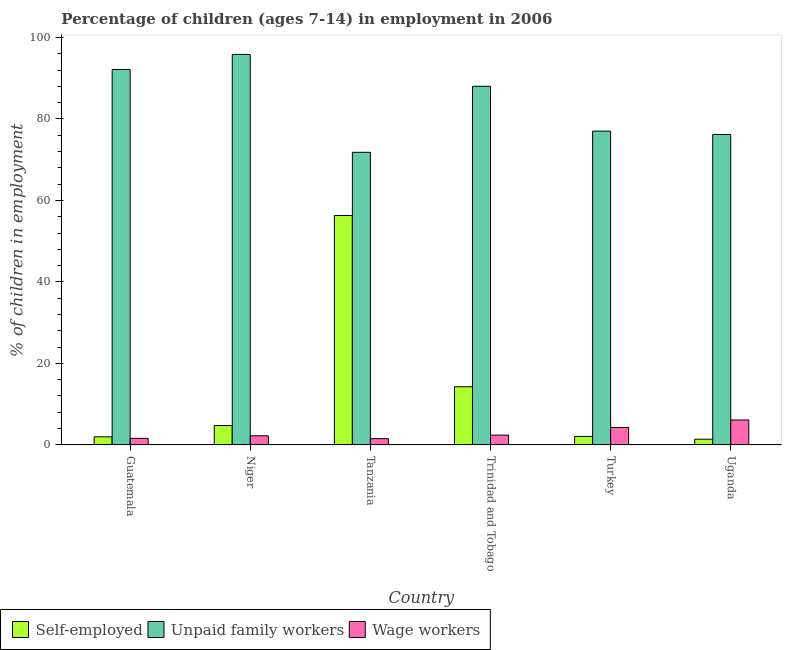How many different coloured bars are there?
Your response must be concise. 3. How many groups of bars are there?
Your response must be concise. 6. Are the number of bars per tick equal to the number of legend labels?
Your answer should be very brief. Yes. Are the number of bars on each tick of the X-axis equal?
Ensure brevity in your answer.  Yes. How many bars are there on the 6th tick from the left?
Offer a very short reply. 3. How many bars are there on the 3rd tick from the right?
Offer a very short reply. 3. What is the label of the 2nd group of bars from the left?
Offer a very short reply. Niger. What is the percentage of self employed children in Niger?
Your answer should be very brief. 4.75. Across all countries, what is the maximum percentage of children employed as unpaid family workers?
Keep it short and to the point. 95.83. Across all countries, what is the minimum percentage of children employed as unpaid family workers?
Offer a terse response. 71.8. In which country was the percentage of self employed children maximum?
Provide a short and direct response. Tanzania. In which country was the percentage of children employed as unpaid family workers minimum?
Give a very brief answer. Tanzania. What is the total percentage of self employed children in the graph?
Give a very brief answer. 80.78. What is the difference between the percentage of children employed as wage workers in Niger and that in Turkey?
Your answer should be very brief. -2.05. What is the difference between the percentage of self employed children in Niger and the percentage of children employed as wage workers in Guatemala?
Your response must be concise. 3.15. What is the average percentage of self employed children per country?
Ensure brevity in your answer.  13.46. What is the difference between the percentage of children employed as wage workers and percentage of self employed children in Uganda?
Keep it short and to the point. 4.71. What is the ratio of the percentage of self employed children in Niger to that in Turkey?
Keep it short and to the point. 2.28. Is the percentage of children employed as unpaid family workers in Trinidad and Tobago less than that in Turkey?
Keep it short and to the point. No. What is the difference between the highest and the second highest percentage of children employed as unpaid family workers?
Give a very brief answer. 3.7. What is the difference between the highest and the lowest percentage of children employed as wage workers?
Your response must be concise. 4.58. In how many countries, is the percentage of children employed as wage workers greater than the average percentage of children employed as wage workers taken over all countries?
Your response must be concise. 2. Is the sum of the percentage of self employed children in Niger and Trinidad and Tobago greater than the maximum percentage of children employed as unpaid family workers across all countries?
Ensure brevity in your answer.  No. What does the 3rd bar from the left in Trinidad and Tobago represents?
Your answer should be compact. Wage workers. What does the 3rd bar from the right in Uganda represents?
Provide a succinct answer. Self-employed. Are all the bars in the graph horizontal?
Provide a succinct answer. No. How many countries are there in the graph?
Your answer should be very brief. 6. Does the graph contain any zero values?
Make the answer very short. No. How many legend labels are there?
Your answer should be compact. 3. What is the title of the graph?
Provide a succinct answer. Percentage of children (ages 7-14) in employment in 2006. What is the label or title of the X-axis?
Make the answer very short. Country. What is the label or title of the Y-axis?
Offer a terse response. % of children in employment. What is the % of children in employment in Self-employed in Guatemala?
Make the answer very short. 1.98. What is the % of children in employment in Unpaid family workers in Guatemala?
Offer a terse response. 92.13. What is the % of children in employment of Self-employed in Niger?
Offer a terse response. 4.75. What is the % of children in employment in Unpaid family workers in Niger?
Offer a very short reply. 95.83. What is the % of children in employment of Wage workers in Niger?
Your answer should be compact. 2.23. What is the % of children in employment of Self-employed in Tanzania?
Give a very brief answer. 56.3. What is the % of children in employment of Unpaid family workers in Tanzania?
Your response must be concise. 71.8. What is the % of children in employment in Wage workers in Tanzania?
Provide a short and direct response. 1.53. What is the % of children in employment of Self-employed in Trinidad and Tobago?
Ensure brevity in your answer.  14.27. What is the % of children in employment of Unpaid family workers in Trinidad and Tobago?
Provide a succinct answer. 88. What is the % of children in employment of Wage workers in Trinidad and Tobago?
Provide a succinct answer. 2.4. What is the % of children in employment in Self-employed in Turkey?
Keep it short and to the point. 2.08. What is the % of children in employment of Unpaid family workers in Turkey?
Keep it short and to the point. 77. What is the % of children in employment of Wage workers in Turkey?
Give a very brief answer. 4.28. What is the % of children in employment of Self-employed in Uganda?
Give a very brief answer. 1.4. What is the % of children in employment in Unpaid family workers in Uganda?
Your response must be concise. 76.18. What is the % of children in employment in Wage workers in Uganda?
Keep it short and to the point. 6.11. Across all countries, what is the maximum % of children in employment of Self-employed?
Your answer should be very brief. 56.3. Across all countries, what is the maximum % of children in employment of Unpaid family workers?
Make the answer very short. 95.83. Across all countries, what is the maximum % of children in employment of Wage workers?
Keep it short and to the point. 6.11. Across all countries, what is the minimum % of children in employment in Self-employed?
Offer a terse response. 1.4. Across all countries, what is the minimum % of children in employment of Unpaid family workers?
Provide a short and direct response. 71.8. Across all countries, what is the minimum % of children in employment in Wage workers?
Make the answer very short. 1.53. What is the total % of children in employment of Self-employed in the graph?
Your response must be concise. 80.78. What is the total % of children in employment in Unpaid family workers in the graph?
Ensure brevity in your answer.  500.94. What is the total % of children in employment of Wage workers in the graph?
Give a very brief answer. 18.15. What is the difference between the % of children in employment of Self-employed in Guatemala and that in Niger?
Make the answer very short. -2.77. What is the difference between the % of children in employment in Unpaid family workers in Guatemala and that in Niger?
Keep it short and to the point. -3.7. What is the difference between the % of children in employment of Wage workers in Guatemala and that in Niger?
Offer a very short reply. -0.63. What is the difference between the % of children in employment in Self-employed in Guatemala and that in Tanzania?
Your answer should be compact. -54.32. What is the difference between the % of children in employment of Unpaid family workers in Guatemala and that in Tanzania?
Offer a terse response. 20.33. What is the difference between the % of children in employment of Wage workers in Guatemala and that in Tanzania?
Ensure brevity in your answer.  0.07. What is the difference between the % of children in employment in Self-employed in Guatemala and that in Trinidad and Tobago?
Your answer should be very brief. -12.29. What is the difference between the % of children in employment in Unpaid family workers in Guatemala and that in Trinidad and Tobago?
Make the answer very short. 4.13. What is the difference between the % of children in employment of Wage workers in Guatemala and that in Trinidad and Tobago?
Your answer should be very brief. -0.8. What is the difference between the % of children in employment of Unpaid family workers in Guatemala and that in Turkey?
Offer a terse response. 15.13. What is the difference between the % of children in employment of Wage workers in Guatemala and that in Turkey?
Keep it short and to the point. -2.68. What is the difference between the % of children in employment of Self-employed in Guatemala and that in Uganda?
Offer a terse response. 0.58. What is the difference between the % of children in employment in Unpaid family workers in Guatemala and that in Uganda?
Your response must be concise. 15.95. What is the difference between the % of children in employment in Wage workers in Guatemala and that in Uganda?
Keep it short and to the point. -4.51. What is the difference between the % of children in employment in Self-employed in Niger and that in Tanzania?
Give a very brief answer. -51.55. What is the difference between the % of children in employment in Unpaid family workers in Niger and that in Tanzania?
Your answer should be very brief. 24.03. What is the difference between the % of children in employment of Self-employed in Niger and that in Trinidad and Tobago?
Make the answer very short. -9.52. What is the difference between the % of children in employment in Unpaid family workers in Niger and that in Trinidad and Tobago?
Offer a very short reply. 7.83. What is the difference between the % of children in employment of Wage workers in Niger and that in Trinidad and Tobago?
Your answer should be compact. -0.17. What is the difference between the % of children in employment of Self-employed in Niger and that in Turkey?
Your answer should be compact. 2.67. What is the difference between the % of children in employment of Unpaid family workers in Niger and that in Turkey?
Provide a succinct answer. 18.83. What is the difference between the % of children in employment of Wage workers in Niger and that in Turkey?
Give a very brief answer. -2.05. What is the difference between the % of children in employment of Self-employed in Niger and that in Uganda?
Your answer should be very brief. 3.35. What is the difference between the % of children in employment in Unpaid family workers in Niger and that in Uganda?
Keep it short and to the point. 19.65. What is the difference between the % of children in employment in Wage workers in Niger and that in Uganda?
Your answer should be very brief. -3.88. What is the difference between the % of children in employment in Self-employed in Tanzania and that in Trinidad and Tobago?
Offer a very short reply. 42.03. What is the difference between the % of children in employment of Unpaid family workers in Tanzania and that in Trinidad and Tobago?
Your answer should be very brief. -16.2. What is the difference between the % of children in employment of Wage workers in Tanzania and that in Trinidad and Tobago?
Your response must be concise. -0.87. What is the difference between the % of children in employment in Self-employed in Tanzania and that in Turkey?
Provide a short and direct response. 54.22. What is the difference between the % of children in employment in Wage workers in Tanzania and that in Turkey?
Ensure brevity in your answer.  -2.75. What is the difference between the % of children in employment of Self-employed in Tanzania and that in Uganda?
Keep it short and to the point. 54.9. What is the difference between the % of children in employment in Unpaid family workers in Tanzania and that in Uganda?
Ensure brevity in your answer.  -4.38. What is the difference between the % of children in employment in Wage workers in Tanzania and that in Uganda?
Provide a short and direct response. -4.58. What is the difference between the % of children in employment of Self-employed in Trinidad and Tobago and that in Turkey?
Provide a succinct answer. 12.19. What is the difference between the % of children in employment in Unpaid family workers in Trinidad and Tobago and that in Turkey?
Make the answer very short. 11. What is the difference between the % of children in employment in Wage workers in Trinidad and Tobago and that in Turkey?
Give a very brief answer. -1.88. What is the difference between the % of children in employment in Self-employed in Trinidad and Tobago and that in Uganda?
Make the answer very short. 12.87. What is the difference between the % of children in employment of Unpaid family workers in Trinidad and Tobago and that in Uganda?
Give a very brief answer. 11.82. What is the difference between the % of children in employment of Wage workers in Trinidad and Tobago and that in Uganda?
Make the answer very short. -3.71. What is the difference between the % of children in employment of Self-employed in Turkey and that in Uganda?
Give a very brief answer. 0.68. What is the difference between the % of children in employment in Unpaid family workers in Turkey and that in Uganda?
Offer a very short reply. 0.82. What is the difference between the % of children in employment in Wage workers in Turkey and that in Uganda?
Provide a short and direct response. -1.83. What is the difference between the % of children in employment in Self-employed in Guatemala and the % of children in employment in Unpaid family workers in Niger?
Provide a succinct answer. -93.85. What is the difference between the % of children in employment of Unpaid family workers in Guatemala and the % of children in employment of Wage workers in Niger?
Keep it short and to the point. 89.9. What is the difference between the % of children in employment in Self-employed in Guatemala and the % of children in employment in Unpaid family workers in Tanzania?
Ensure brevity in your answer.  -69.82. What is the difference between the % of children in employment in Self-employed in Guatemala and the % of children in employment in Wage workers in Tanzania?
Keep it short and to the point. 0.45. What is the difference between the % of children in employment in Unpaid family workers in Guatemala and the % of children in employment in Wage workers in Tanzania?
Your answer should be compact. 90.6. What is the difference between the % of children in employment of Self-employed in Guatemala and the % of children in employment of Unpaid family workers in Trinidad and Tobago?
Offer a terse response. -86.02. What is the difference between the % of children in employment in Self-employed in Guatemala and the % of children in employment in Wage workers in Trinidad and Tobago?
Offer a very short reply. -0.42. What is the difference between the % of children in employment in Unpaid family workers in Guatemala and the % of children in employment in Wage workers in Trinidad and Tobago?
Keep it short and to the point. 89.73. What is the difference between the % of children in employment of Self-employed in Guatemala and the % of children in employment of Unpaid family workers in Turkey?
Give a very brief answer. -75.02. What is the difference between the % of children in employment of Unpaid family workers in Guatemala and the % of children in employment of Wage workers in Turkey?
Offer a very short reply. 87.85. What is the difference between the % of children in employment in Self-employed in Guatemala and the % of children in employment in Unpaid family workers in Uganda?
Keep it short and to the point. -74.2. What is the difference between the % of children in employment in Self-employed in Guatemala and the % of children in employment in Wage workers in Uganda?
Provide a succinct answer. -4.13. What is the difference between the % of children in employment in Unpaid family workers in Guatemala and the % of children in employment in Wage workers in Uganda?
Give a very brief answer. 86.02. What is the difference between the % of children in employment in Self-employed in Niger and the % of children in employment in Unpaid family workers in Tanzania?
Provide a succinct answer. -67.05. What is the difference between the % of children in employment of Self-employed in Niger and the % of children in employment of Wage workers in Tanzania?
Ensure brevity in your answer.  3.22. What is the difference between the % of children in employment in Unpaid family workers in Niger and the % of children in employment in Wage workers in Tanzania?
Give a very brief answer. 94.3. What is the difference between the % of children in employment of Self-employed in Niger and the % of children in employment of Unpaid family workers in Trinidad and Tobago?
Your answer should be very brief. -83.25. What is the difference between the % of children in employment in Self-employed in Niger and the % of children in employment in Wage workers in Trinidad and Tobago?
Keep it short and to the point. 2.35. What is the difference between the % of children in employment in Unpaid family workers in Niger and the % of children in employment in Wage workers in Trinidad and Tobago?
Provide a short and direct response. 93.43. What is the difference between the % of children in employment in Self-employed in Niger and the % of children in employment in Unpaid family workers in Turkey?
Ensure brevity in your answer.  -72.25. What is the difference between the % of children in employment in Self-employed in Niger and the % of children in employment in Wage workers in Turkey?
Provide a succinct answer. 0.47. What is the difference between the % of children in employment of Unpaid family workers in Niger and the % of children in employment of Wage workers in Turkey?
Offer a very short reply. 91.55. What is the difference between the % of children in employment in Self-employed in Niger and the % of children in employment in Unpaid family workers in Uganda?
Offer a terse response. -71.43. What is the difference between the % of children in employment of Self-employed in Niger and the % of children in employment of Wage workers in Uganda?
Give a very brief answer. -1.36. What is the difference between the % of children in employment of Unpaid family workers in Niger and the % of children in employment of Wage workers in Uganda?
Give a very brief answer. 89.72. What is the difference between the % of children in employment in Self-employed in Tanzania and the % of children in employment in Unpaid family workers in Trinidad and Tobago?
Your answer should be compact. -31.7. What is the difference between the % of children in employment in Self-employed in Tanzania and the % of children in employment in Wage workers in Trinidad and Tobago?
Your response must be concise. 53.9. What is the difference between the % of children in employment in Unpaid family workers in Tanzania and the % of children in employment in Wage workers in Trinidad and Tobago?
Provide a short and direct response. 69.4. What is the difference between the % of children in employment in Self-employed in Tanzania and the % of children in employment in Unpaid family workers in Turkey?
Keep it short and to the point. -20.7. What is the difference between the % of children in employment of Self-employed in Tanzania and the % of children in employment of Wage workers in Turkey?
Your response must be concise. 52.02. What is the difference between the % of children in employment of Unpaid family workers in Tanzania and the % of children in employment of Wage workers in Turkey?
Offer a very short reply. 67.52. What is the difference between the % of children in employment in Self-employed in Tanzania and the % of children in employment in Unpaid family workers in Uganda?
Your answer should be very brief. -19.88. What is the difference between the % of children in employment of Self-employed in Tanzania and the % of children in employment of Wage workers in Uganda?
Your response must be concise. 50.19. What is the difference between the % of children in employment in Unpaid family workers in Tanzania and the % of children in employment in Wage workers in Uganda?
Keep it short and to the point. 65.69. What is the difference between the % of children in employment of Self-employed in Trinidad and Tobago and the % of children in employment of Unpaid family workers in Turkey?
Offer a very short reply. -62.73. What is the difference between the % of children in employment in Self-employed in Trinidad and Tobago and the % of children in employment in Wage workers in Turkey?
Ensure brevity in your answer.  9.99. What is the difference between the % of children in employment in Unpaid family workers in Trinidad and Tobago and the % of children in employment in Wage workers in Turkey?
Keep it short and to the point. 83.72. What is the difference between the % of children in employment of Self-employed in Trinidad and Tobago and the % of children in employment of Unpaid family workers in Uganda?
Your answer should be very brief. -61.91. What is the difference between the % of children in employment of Self-employed in Trinidad and Tobago and the % of children in employment of Wage workers in Uganda?
Give a very brief answer. 8.16. What is the difference between the % of children in employment in Unpaid family workers in Trinidad and Tobago and the % of children in employment in Wage workers in Uganda?
Ensure brevity in your answer.  81.89. What is the difference between the % of children in employment of Self-employed in Turkey and the % of children in employment of Unpaid family workers in Uganda?
Offer a very short reply. -74.1. What is the difference between the % of children in employment in Self-employed in Turkey and the % of children in employment in Wage workers in Uganda?
Offer a very short reply. -4.03. What is the difference between the % of children in employment of Unpaid family workers in Turkey and the % of children in employment of Wage workers in Uganda?
Provide a short and direct response. 70.89. What is the average % of children in employment in Self-employed per country?
Provide a succinct answer. 13.46. What is the average % of children in employment of Unpaid family workers per country?
Keep it short and to the point. 83.49. What is the average % of children in employment of Wage workers per country?
Ensure brevity in your answer.  3.02. What is the difference between the % of children in employment of Self-employed and % of children in employment of Unpaid family workers in Guatemala?
Provide a succinct answer. -90.15. What is the difference between the % of children in employment of Self-employed and % of children in employment of Wage workers in Guatemala?
Your response must be concise. 0.38. What is the difference between the % of children in employment in Unpaid family workers and % of children in employment in Wage workers in Guatemala?
Ensure brevity in your answer.  90.53. What is the difference between the % of children in employment in Self-employed and % of children in employment in Unpaid family workers in Niger?
Keep it short and to the point. -91.08. What is the difference between the % of children in employment in Self-employed and % of children in employment in Wage workers in Niger?
Provide a short and direct response. 2.52. What is the difference between the % of children in employment of Unpaid family workers and % of children in employment of Wage workers in Niger?
Provide a succinct answer. 93.6. What is the difference between the % of children in employment in Self-employed and % of children in employment in Unpaid family workers in Tanzania?
Your answer should be very brief. -15.5. What is the difference between the % of children in employment of Self-employed and % of children in employment of Wage workers in Tanzania?
Provide a succinct answer. 54.77. What is the difference between the % of children in employment in Unpaid family workers and % of children in employment in Wage workers in Tanzania?
Offer a terse response. 70.27. What is the difference between the % of children in employment in Self-employed and % of children in employment in Unpaid family workers in Trinidad and Tobago?
Offer a very short reply. -73.73. What is the difference between the % of children in employment in Self-employed and % of children in employment in Wage workers in Trinidad and Tobago?
Provide a short and direct response. 11.87. What is the difference between the % of children in employment in Unpaid family workers and % of children in employment in Wage workers in Trinidad and Tobago?
Give a very brief answer. 85.6. What is the difference between the % of children in employment of Self-employed and % of children in employment of Unpaid family workers in Turkey?
Your response must be concise. -74.92. What is the difference between the % of children in employment in Unpaid family workers and % of children in employment in Wage workers in Turkey?
Ensure brevity in your answer.  72.72. What is the difference between the % of children in employment in Self-employed and % of children in employment in Unpaid family workers in Uganda?
Offer a terse response. -74.78. What is the difference between the % of children in employment in Self-employed and % of children in employment in Wage workers in Uganda?
Provide a short and direct response. -4.71. What is the difference between the % of children in employment of Unpaid family workers and % of children in employment of Wage workers in Uganda?
Provide a succinct answer. 70.07. What is the ratio of the % of children in employment of Self-employed in Guatemala to that in Niger?
Give a very brief answer. 0.42. What is the ratio of the % of children in employment of Unpaid family workers in Guatemala to that in Niger?
Provide a succinct answer. 0.96. What is the ratio of the % of children in employment of Wage workers in Guatemala to that in Niger?
Make the answer very short. 0.72. What is the ratio of the % of children in employment in Self-employed in Guatemala to that in Tanzania?
Provide a short and direct response. 0.04. What is the ratio of the % of children in employment in Unpaid family workers in Guatemala to that in Tanzania?
Your response must be concise. 1.28. What is the ratio of the % of children in employment in Wage workers in Guatemala to that in Tanzania?
Your answer should be very brief. 1.05. What is the ratio of the % of children in employment of Self-employed in Guatemala to that in Trinidad and Tobago?
Offer a terse response. 0.14. What is the ratio of the % of children in employment in Unpaid family workers in Guatemala to that in Trinidad and Tobago?
Offer a terse response. 1.05. What is the ratio of the % of children in employment of Self-employed in Guatemala to that in Turkey?
Keep it short and to the point. 0.95. What is the ratio of the % of children in employment in Unpaid family workers in Guatemala to that in Turkey?
Provide a short and direct response. 1.2. What is the ratio of the % of children in employment of Wage workers in Guatemala to that in Turkey?
Your response must be concise. 0.37. What is the ratio of the % of children in employment in Self-employed in Guatemala to that in Uganda?
Your answer should be compact. 1.41. What is the ratio of the % of children in employment in Unpaid family workers in Guatemala to that in Uganda?
Provide a short and direct response. 1.21. What is the ratio of the % of children in employment of Wage workers in Guatemala to that in Uganda?
Give a very brief answer. 0.26. What is the ratio of the % of children in employment in Self-employed in Niger to that in Tanzania?
Your answer should be very brief. 0.08. What is the ratio of the % of children in employment of Unpaid family workers in Niger to that in Tanzania?
Provide a succinct answer. 1.33. What is the ratio of the % of children in employment in Wage workers in Niger to that in Tanzania?
Ensure brevity in your answer.  1.46. What is the ratio of the % of children in employment of Self-employed in Niger to that in Trinidad and Tobago?
Offer a terse response. 0.33. What is the ratio of the % of children in employment in Unpaid family workers in Niger to that in Trinidad and Tobago?
Your answer should be compact. 1.09. What is the ratio of the % of children in employment in Wage workers in Niger to that in Trinidad and Tobago?
Provide a succinct answer. 0.93. What is the ratio of the % of children in employment in Self-employed in Niger to that in Turkey?
Make the answer very short. 2.28. What is the ratio of the % of children in employment in Unpaid family workers in Niger to that in Turkey?
Give a very brief answer. 1.24. What is the ratio of the % of children in employment in Wage workers in Niger to that in Turkey?
Your answer should be very brief. 0.52. What is the ratio of the % of children in employment of Self-employed in Niger to that in Uganda?
Ensure brevity in your answer.  3.39. What is the ratio of the % of children in employment of Unpaid family workers in Niger to that in Uganda?
Offer a terse response. 1.26. What is the ratio of the % of children in employment of Wage workers in Niger to that in Uganda?
Your answer should be very brief. 0.36. What is the ratio of the % of children in employment of Self-employed in Tanzania to that in Trinidad and Tobago?
Give a very brief answer. 3.95. What is the ratio of the % of children in employment in Unpaid family workers in Tanzania to that in Trinidad and Tobago?
Your answer should be compact. 0.82. What is the ratio of the % of children in employment in Wage workers in Tanzania to that in Trinidad and Tobago?
Your response must be concise. 0.64. What is the ratio of the % of children in employment in Self-employed in Tanzania to that in Turkey?
Your response must be concise. 27.07. What is the ratio of the % of children in employment in Unpaid family workers in Tanzania to that in Turkey?
Provide a short and direct response. 0.93. What is the ratio of the % of children in employment in Wage workers in Tanzania to that in Turkey?
Give a very brief answer. 0.36. What is the ratio of the % of children in employment of Self-employed in Tanzania to that in Uganda?
Provide a succinct answer. 40.21. What is the ratio of the % of children in employment in Unpaid family workers in Tanzania to that in Uganda?
Your answer should be compact. 0.94. What is the ratio of the % of children in employment in Wage workers in Tanzania to that in Uganda?
Your answer should be very brief. 0.25. What is the ratio of the % of children in employment in Self-employed in Trinidad and Tobago to that in Turkey?
Provide a succinct answer. 6.86. What is the ratio of the % of children in employment in Unpaid family workers in Trinidad and Tobago to that in Turkey?
Ensure brevity in your answer.  1.14. What is the ratio of the % of children in employment in Wage workers in Trinidad and Tobago to that in Turkey?
Offer a very short reply. 0.56. What is the ratio of the % of children in employment in Self-employed in Trinidad and Tobago to that in Uganda?
Ensure brevity in your answer.  10.19. What is the ratio of the % of children in employment in Unpaid family workers in Trinidad and Tobago to that in Uganda?
Provide a short and direct response. 1.16. What is the ratio of the % of children in employment in Wage workers in Trinidad and Tobago to that in Uganda?
Your answer should be compact. 0.39. What is the ratio of the % of children in employment in Self-employed in Turkey to that in Uganda?
Provide a succinct answer. 1.49. What is the ratio of the % of children in employment in Unpaid family workers in Turkey to that in Uganda?
Provide a short and direct response. 1.01. What is the ratio of the % of children in employment of Wage workers in Turkey to that in Uganda?
Provide a short and direct response. 0.7. What is the difference between the highest and the second highest % of children in employment of Self-employed?
Your response must be concise. 42.03. What is the difference between the highest and the second highest % of children in employment of Unpaid family workers?
Offer a very short reply. 3.7. What is the difference between the highest and the second highest % of children in employment in Wage workers?
Your response must be concise. 1.83. What is the difference between the highest and the lowest % of children in employment of Self-employed?
Provide a succinct answer. 54.9. What is the difference between the highest and the lowest % of children in employment of Unpaid family workers?
Provide a succinct answer. 24.03. What is the difference between the highest and the lowest % of children in employment of Wage workers?
Your answer should be very brief. 4.58. 